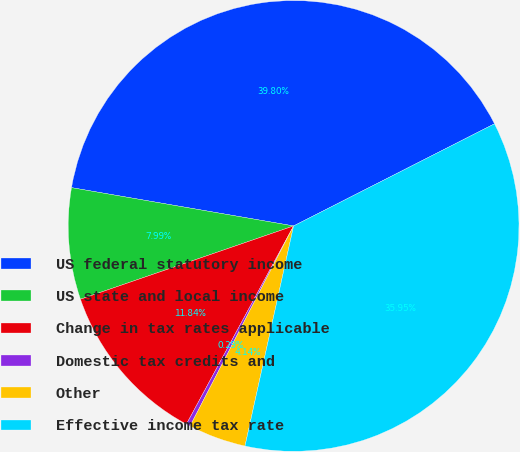Convert chart. <chart><loc_0><loc_0><loc_500><loc_500><pie_chart><fcel>US federal statutory income<fcel>US state and local income<fcel>Change in tax rates applicable<fcel>Domestic tax credits and<fcel>Other<fcel>Effective income tax rate<nl><fcel>39.8%<fcel>7.99%<fcel>11.84%<fcel>0.29%<fcel>4.14%<fcel>35.95%<nl></chart> 